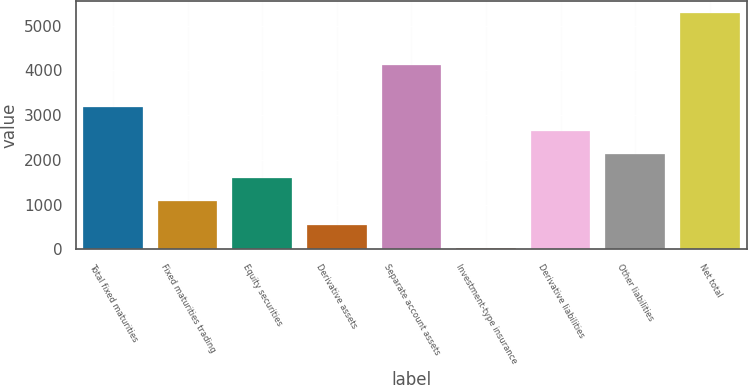Convert chart. <chart><loc_0><loc_0><loc_500><loc_500><bar_chart><fcel>Total fixed maturities<fcel>Fixed maturities trading<fcel>Equity securities<fcel>Derivative assets<fcel>Separate account assets<fcel>Investment-type insurance<fcel>Derivative liabilities<fcel>Other liabilities<fcel>Net total<nl><fcel>3175.34<fcel>1074.18<fcel>1599.47<fcel>548.89<fcel>4120.7<fcel>23.6<fcel>2650.05<fcel>2124.76<fcel>5276.5<nl></chart> 